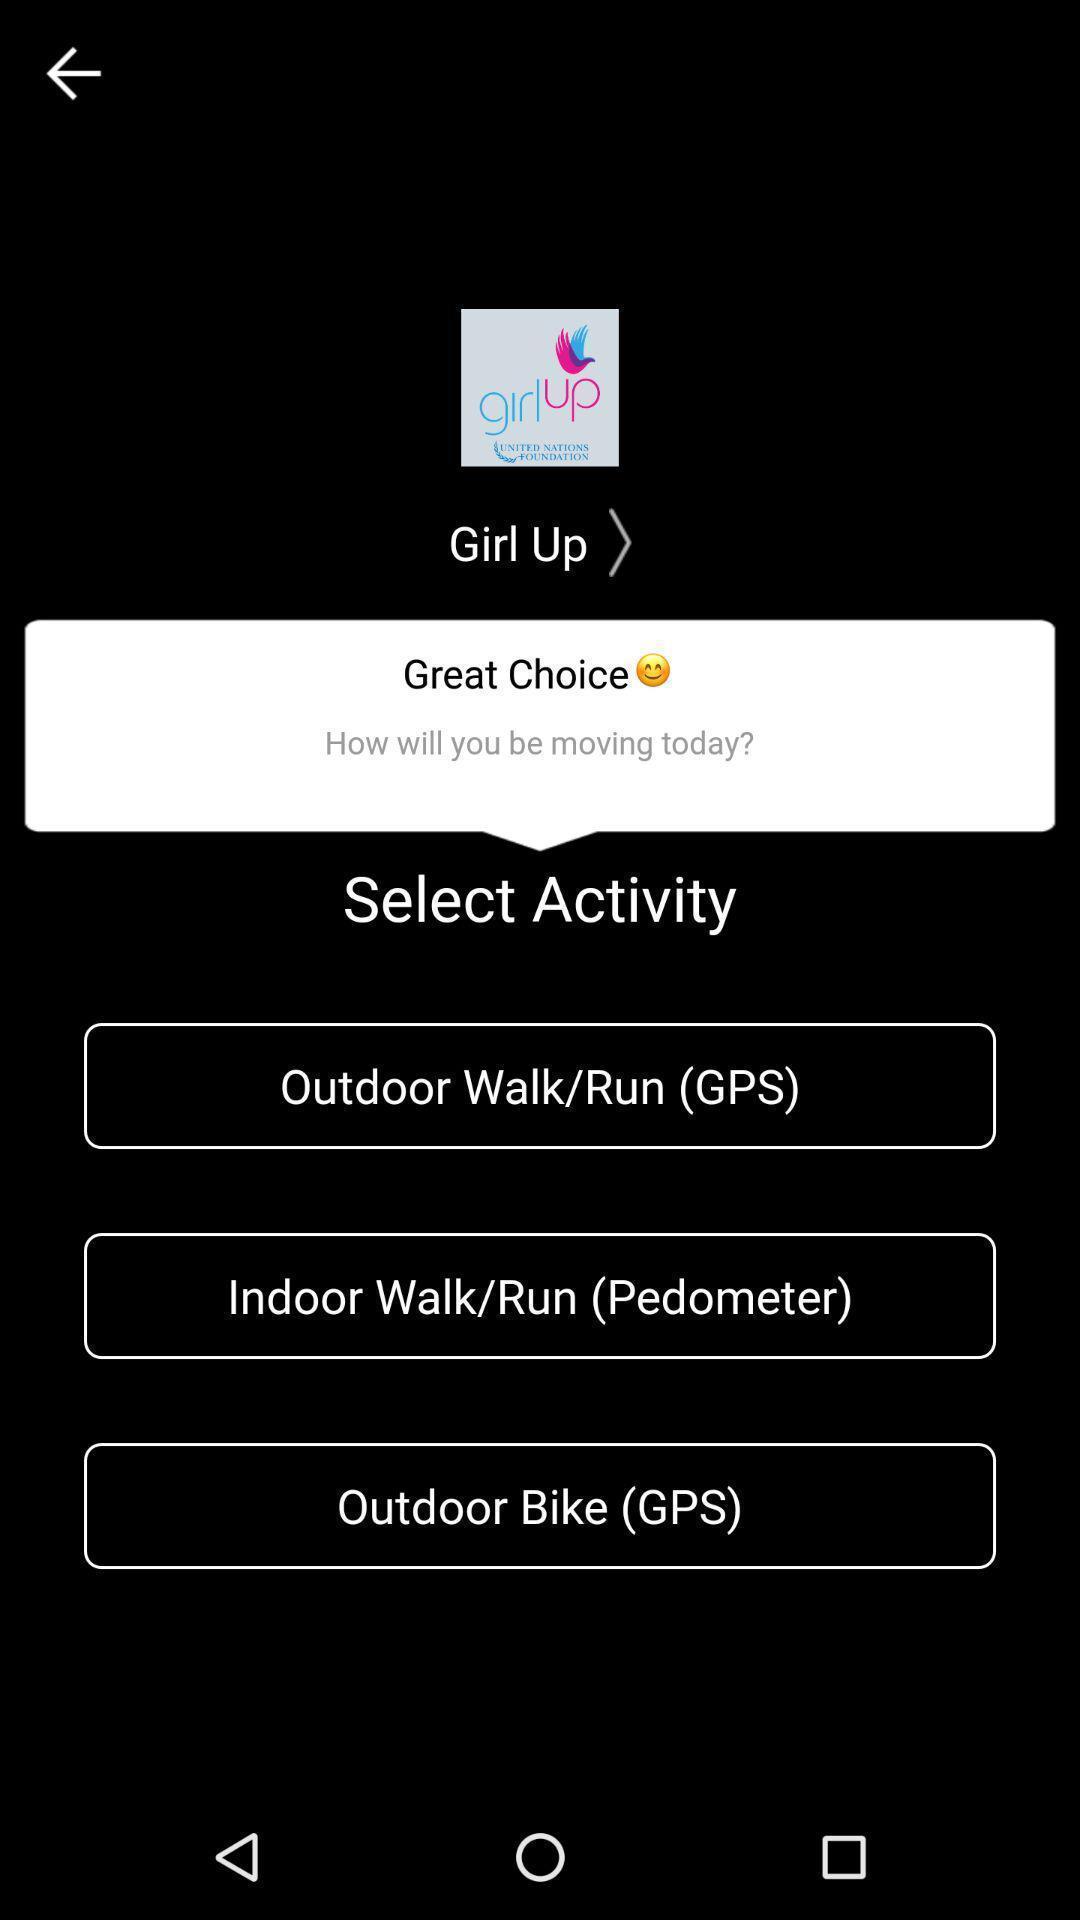Explain the elements present in this screenshot. Screen displaying multiple options to select the activity. 